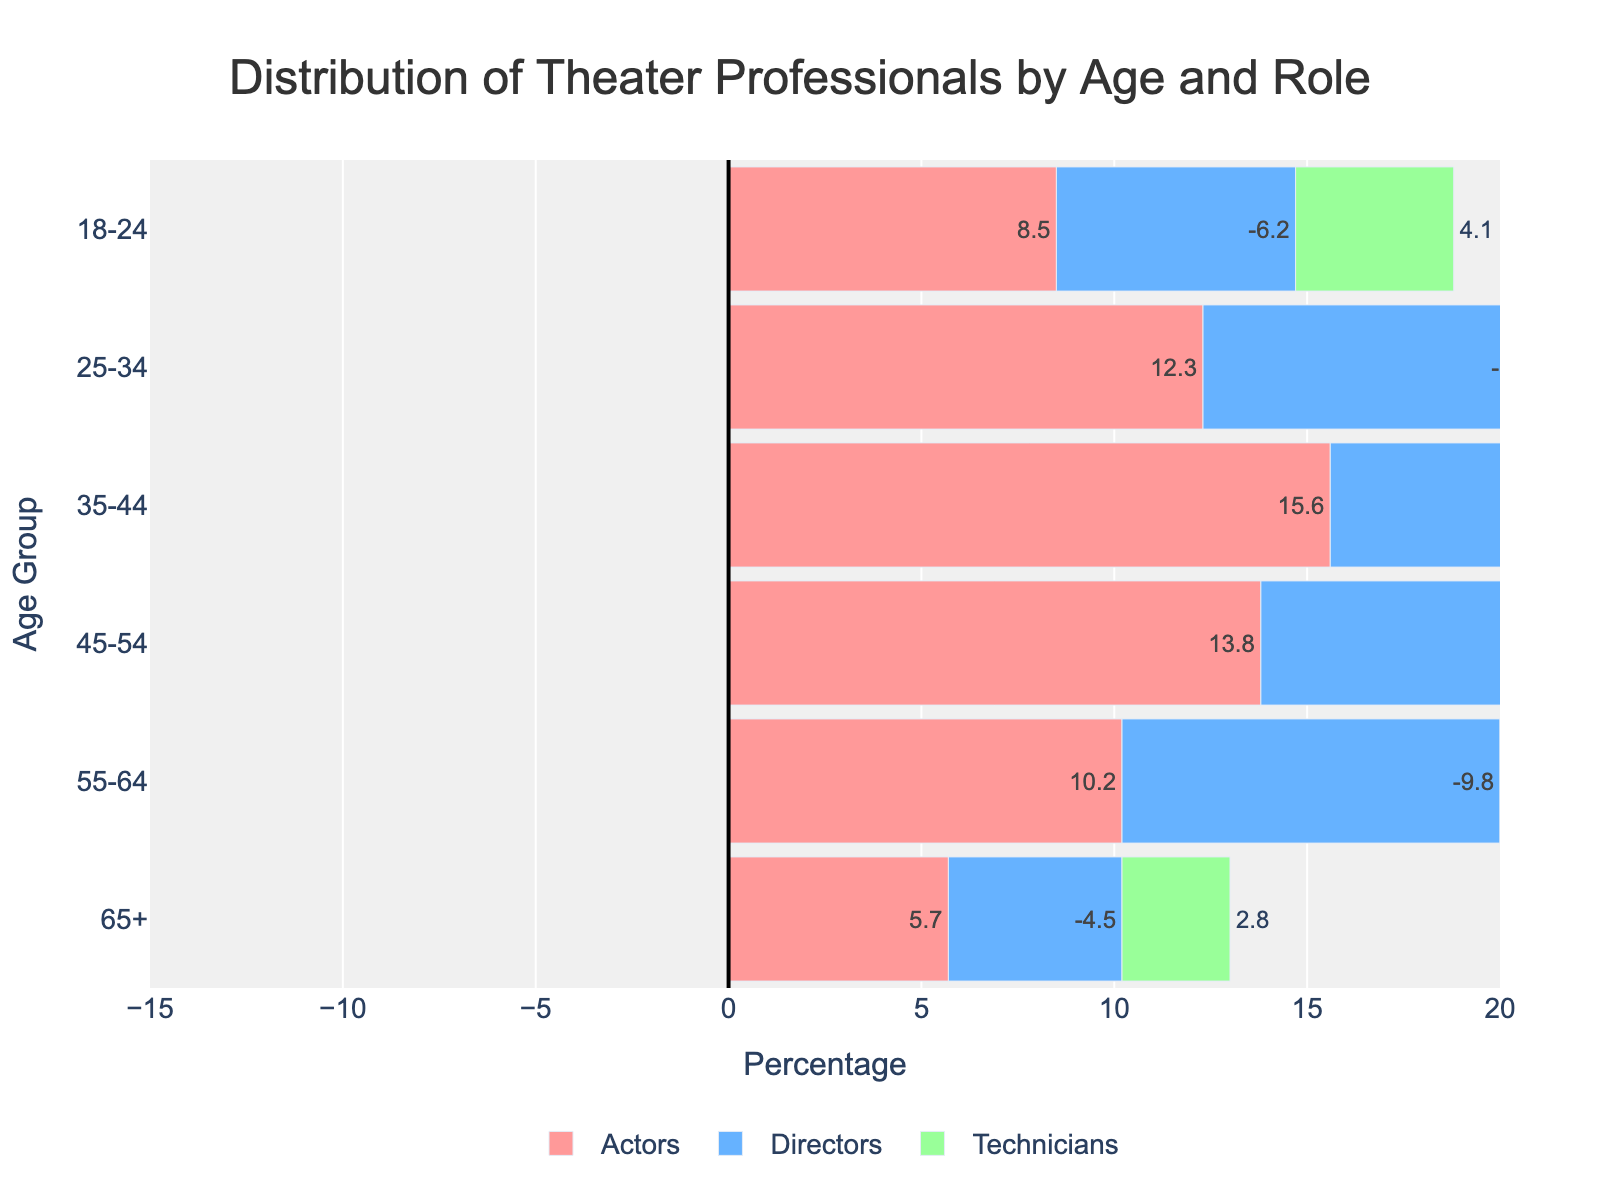What is the title of the figure? The title is located at the top of the figure and gives a clear idea about the content being represented. In this case, it is displayed as 'Distribution of Theater Professionals by Age and Role'.
Answer: Distribution of Theater Professionals by Age and Role What are the three roles represented in the figure? There are three distinct groups shown in different colors. Each group represents a different role: Actors (in pink), Directors (in blue), and Technicians (in green).
Answer: Actors, Directors, Technicians Which age group has the highest percentage of actors? By examining the length of the bars for actors (in pink), the age group 35-44 has the most extended bar at 15.6%.
Answer: 35-44 How many age groups are there on the y-axis? The y-axis shows different age groups ranging from 18-24, 25-34, 35-44, 45-54, 55-64, to 65+. Counting these groups gives a total of six.
Answer: 6 Which age group has the lowest percentage of directors? By checking the negative blue bars, we can see that the age group 65+ has the shortest bar representing -4.5%. This indicates the lowest percentage of directors.
Answer: 65+ What is the difference in the percentage of technicians between the age groups 25-34 and 35-44? The percentages for technicians in these age groups are 7.6% and 9.2% respectively. The difference is calculated as 9.2% - 7.6% = 1.6%.
Answer: 1.6% Which age group has a higher percentage of actors than technicians? By comparing the length of the bars for actors and technicians in each age group, it's evident that age groups 18-24, 25-34, 35-44, 45-54, and 55-64 all have higher percentages of actors than technicians.
Answer: 18-24, 25-34, 35-44, 45-54, 55-64 How does the percentage of directors change across age groups? To understand the trend, observe the length of the blue bars across the age groups. They start at -6.2%, increase in the mid-age groups, and decrease again to -4.5% for 65+. The trend shows an increase up to 45-54 and then a decline.
Answer: Increases up to 45-54, then decreases Compare the percentage of actors and directors in the age group 45-54. Which one is higher and by how much? The percentage of actors in this age group is 13.8%, and the percentage of directors is -11.3%. Taking the absolute values, actors are 13.8% and directors are 11.3%, so actors are higher by 2.5%.
Answer: Actors, by 2.5% What is the combined percentage of directors and technicians in the age group 55-64? To find the combined percentage, sum the absolute values: Directors (9.8%) + Technicians (6.3%) = 16.1%.
Answer: 16.1% 